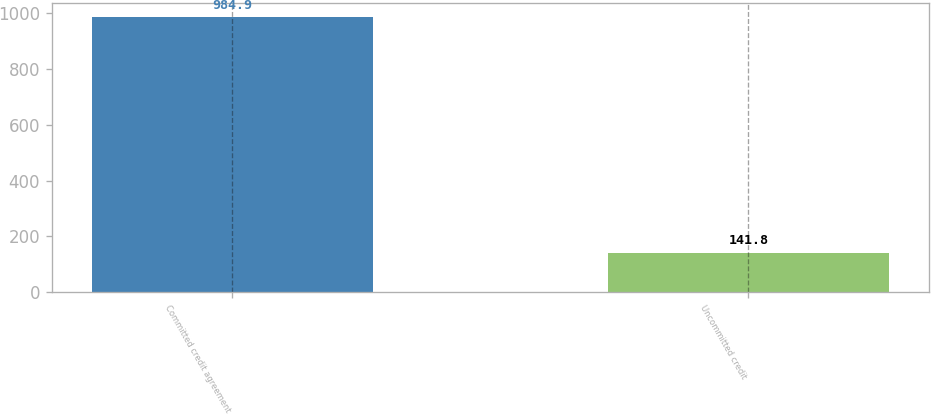Convert chart. <chart><loc_0><loc_0><loc_500><loc_500><bar_chart><fcel>Committed credit agreement<fcel>Uncommitted credit<nl><fcel>984.9<fcel>141.8<nl></chart> 